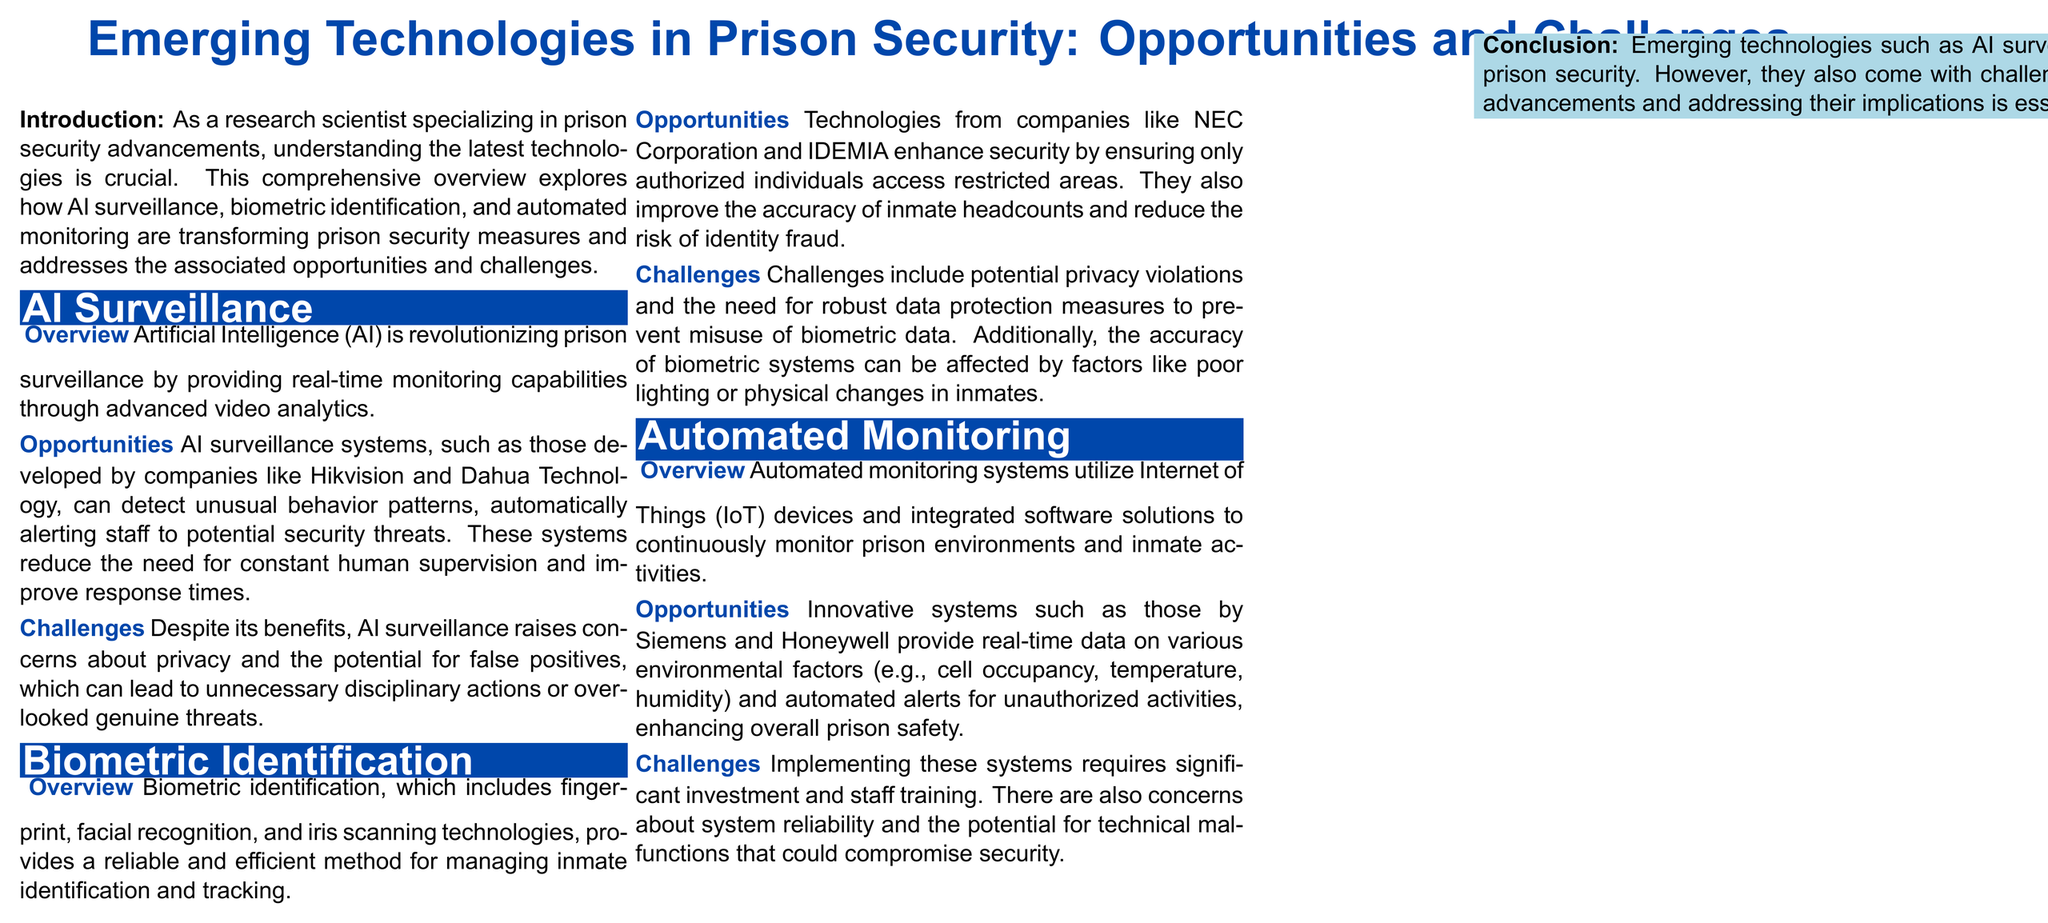What technology is transforming prison surveillance? The technology transforming prison surveillance is Artificial Intelligence (AI), as mentioned in the overview section.
Answer: Artificial Intelligence (AI) Which companies are mentioned in relation to AI surveillance systems? The companies mentioned in relation to AI surveillance systems are Hikvision and Dahua Technology.
Answer: Hikvision and Dahua Technology What type of biometric technologies are highlighted? The highlighted biometric technologies include fingerprint, facial recognition, and iris scanning.
Answer: fingerprint, facial recognition, and iris scanning What system provides real-time monitoring of environmental factors in prisons? The system that provides real-time monitoring of environmental factors in prisons is automated monitoring systems utilizing IoT devices.
Answer: automated monitoring systems What is a significant challenge of implementing automated monitoring systems? A significant challenge of implementing automated monitoring systems is the need for significant investment and staff training.
Answer: significant investment and staff training What is the main concern associated with AI surveillance? The main concern associated with AI surveillance is privacy.
Answer: privacy Which company is mentioned in relation to biometric identification? The company mentioned in relation to biometric identification is NEC Corporation.
Answer: NEC Corporation What do AI surveillance systems improve in response times? AI surveillance systems improve response times by automatically alerting staff to potential security threats.
Answer: automatically alerting staff What environmental factors are monitored by automated systems? The environmental factors monitored by automated systems include cell occupancy, temperature, and humidity.
Answer: cell occupancy, temperature, humidity 